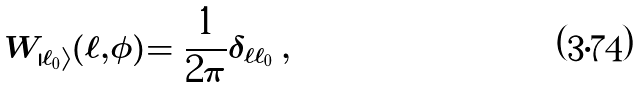Convert formula to latex. <formula><loc_0><loc_0><loc_500><loc_500>W _ { | \ell _ { 0 } \rangle } ( \ell , \phi ) = \frac { 1 } { 2 \pi } \delta _ { \ell \ell _ { 0 } } \, ,</formula> 